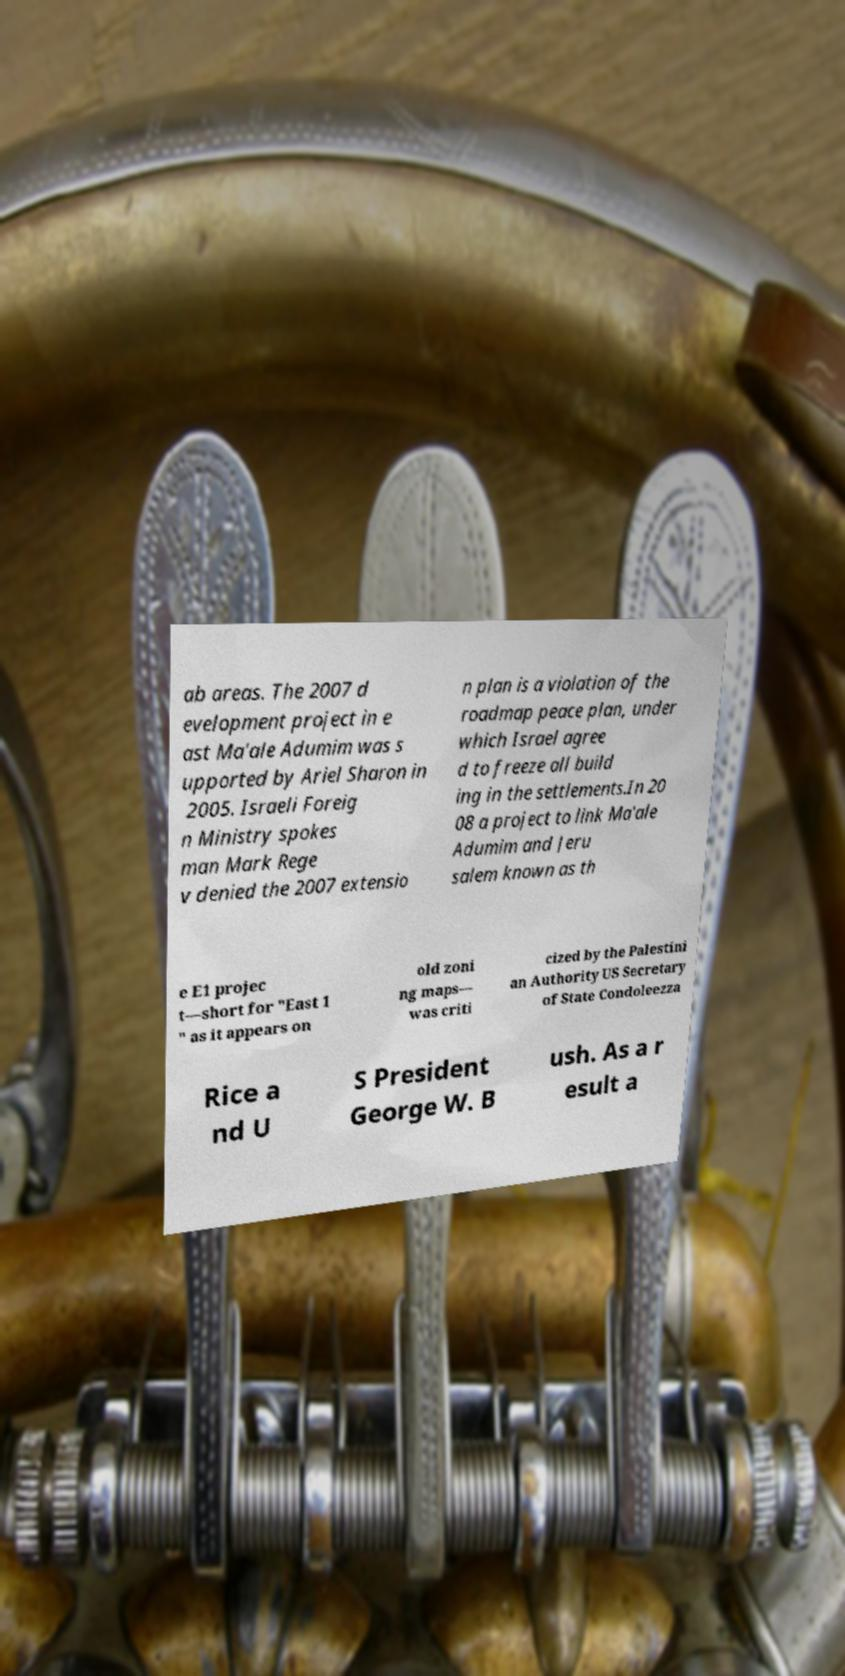Please identify and transcribe the text found in this image. ab areas. The 2007 d evelopment project in e ast Ma'ale Adumim was s upported by Ariel Sharon in 2005. Israeli Foreig n Ministry spokes man Mark Rege v denied the 2007 extensio n plan is a violation of the roadmap peace plan, under which Israel agree d to freeze all build ing in the settlements.In 20 08 a project to link Ma'ale Adumim and Jeru salem known as th e E1 projec t—short for "East 1 " as it appears on old zoni ng maps— was criti cized by the Palestini an Authority US Secretary of State Condoleezza Rice a nd U S President George W. B ush. As a r esult a 